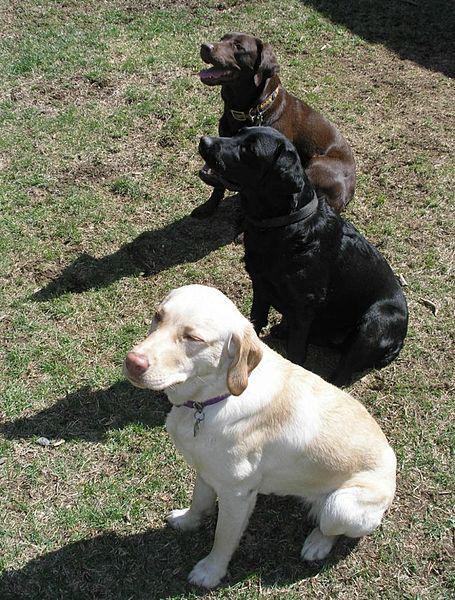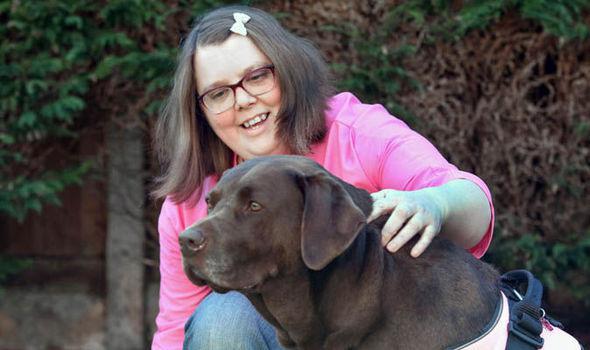The first image is the image on the left, the second image is the image on the right. For the images shown, is this caption "A yellow dog is next to a woman." true? Answer yes or no. No. The first image is the image on the left, the second image is the image on the right. Examine the images to the left and right. Is the description "There are no humans in the image on the right." accurate? Answer yes or no. No. 